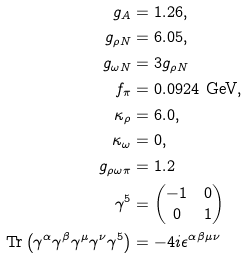<formula> <loc_0><loc_0><loc_500><loc_500>g _ { A } & = 1 . 2 6 , \\ g _ { \rho N } & = 6 . 0 5 , \\ g _ { \omega N } & = 3 g _ { \rho N } \\ f _ { \pi } & = 0 . 0 9 2 4 \ \text {GeV} , \\ \kappa _ { \rho } & = 6 . 0 , \\ \kappa _ { \omega } & = 0 , \\ g _ { \rho \omega \pi } & = 1 . 2 \\ \gamma ^ { 5 } & = \begin{pmatrix} - 1 & 0 \\ 0 & 1 \end{pmatrix} \\ \text {Tr} \left ( \gamma ^ { \alpha } \gamma ^ { \beta } \gamma ^ { \mu } \gamma ^ { \nu } \gamma ^ { 5 } \right ) & = - 4 i \epsilon ^ { \alpha \beta \mu \nu } \</formula> 